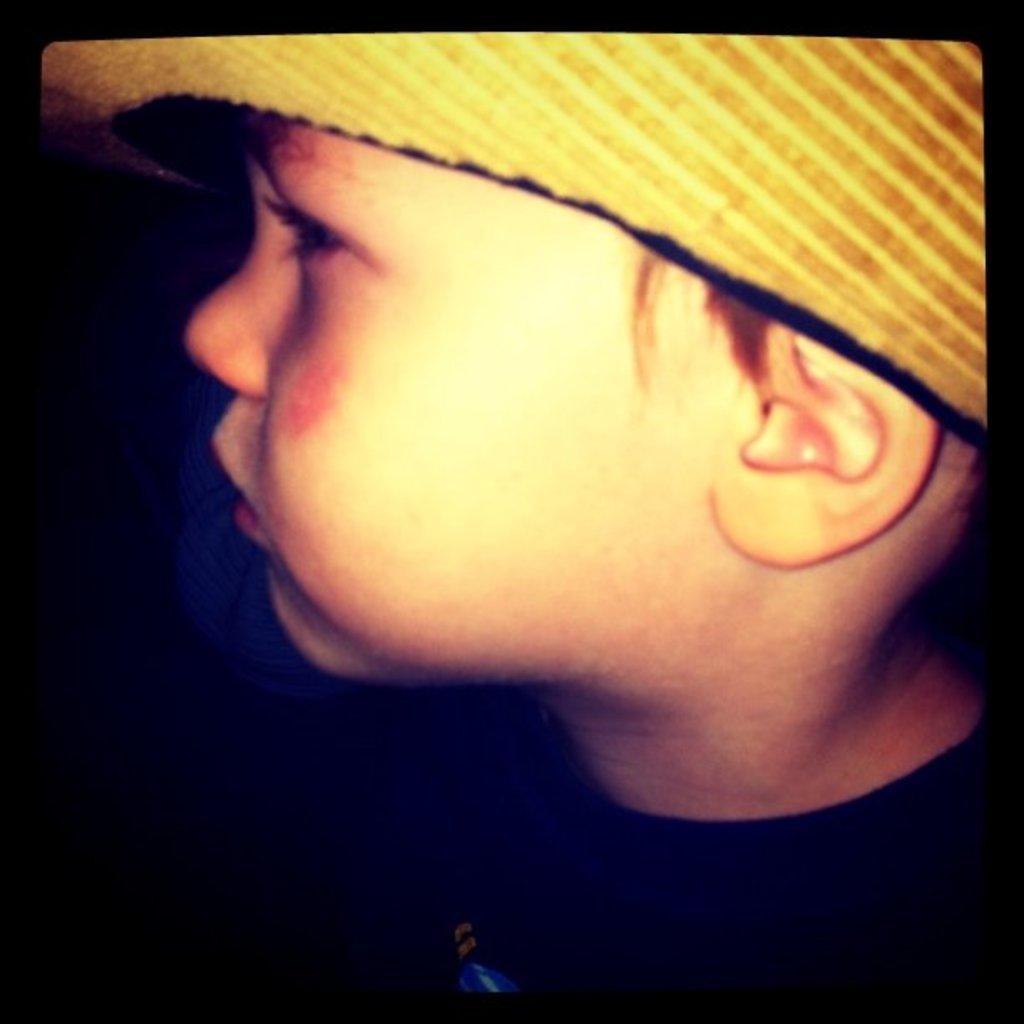How would you summarize this image in a sentence or two? In this image we can see a boy wearing a hat. 